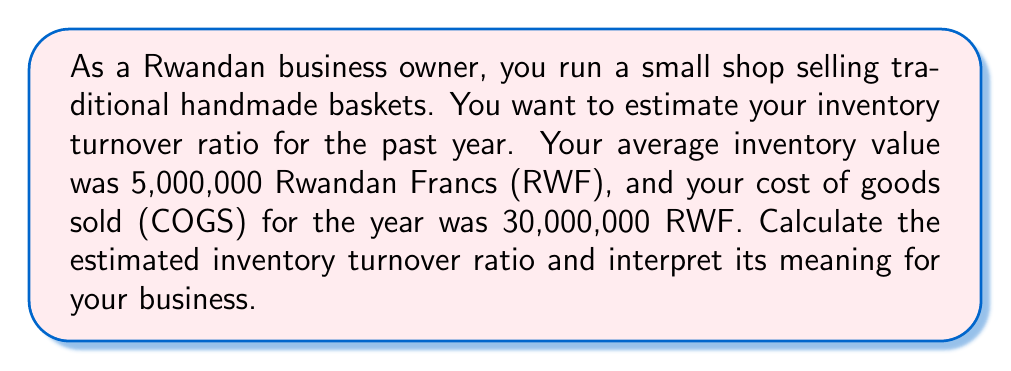Teach me how to tackle this problem. To calculate the inventory turnover ratio, we use the following formula:

$$\text{Inventory Turnover Ratio} = \frac{\text{Cost of Goods Sold (COGS)}}{\text{Average Inventory}}$$

Given:
- Cost of Goods Sold (COGS) = 30,000,000 RWF
- Average Inventory = 5,000,000 RWF

Let's substitute these values into the formula:

$$\text{Inventory Turnover Ratio} = \frac{30,000,000 \text{ RWF}}{5,000,000 \text{ RWF}}$$

$$\text{Inventory Turnover Ratio} = 6$$

Interpretation:
An inventory turnover ratio of 6 means that, on average, you sell and replace your entire inventory 6 times per year. This can be further understood by calculating the average days to sell inventory:

$$\text{Days to Sell Inventory} = \frac{365 \text{ days}}{\text{Inventory Turnover Ratio}}$$

$$\text{Days to Sell Inventory} = \frac{365}{6} \approx 60.83 \text{ days}$$

This means that, on average, it takes about 61 days to sell through your entire inventory.

For a small shop selling handmade baskets in Rwanda, a turnover ratio of 6 is generally good, indicating that you're efficiently managing your inventory. However, you should compare this to industry standards and your historical performance to get a better understanding of your business's efficiency.
Answer: The estimated inventory turnover ratio is 6, meaning the business sells and replaces its entire inventory approximately 6 times per year, or every 61 days on average. 